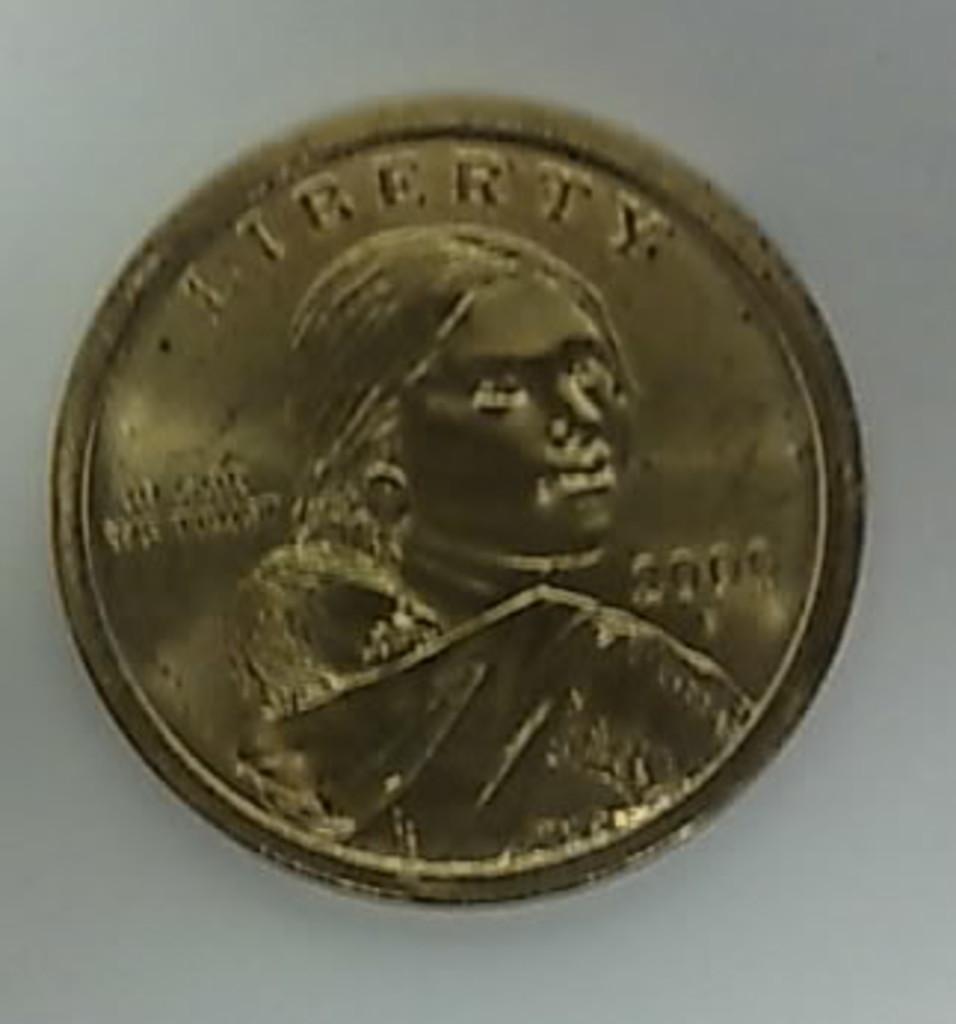What is the coin titled?
Offer a very short reply. Liberty. What year was this coin made in?
Your answer should be compact. 2000. 